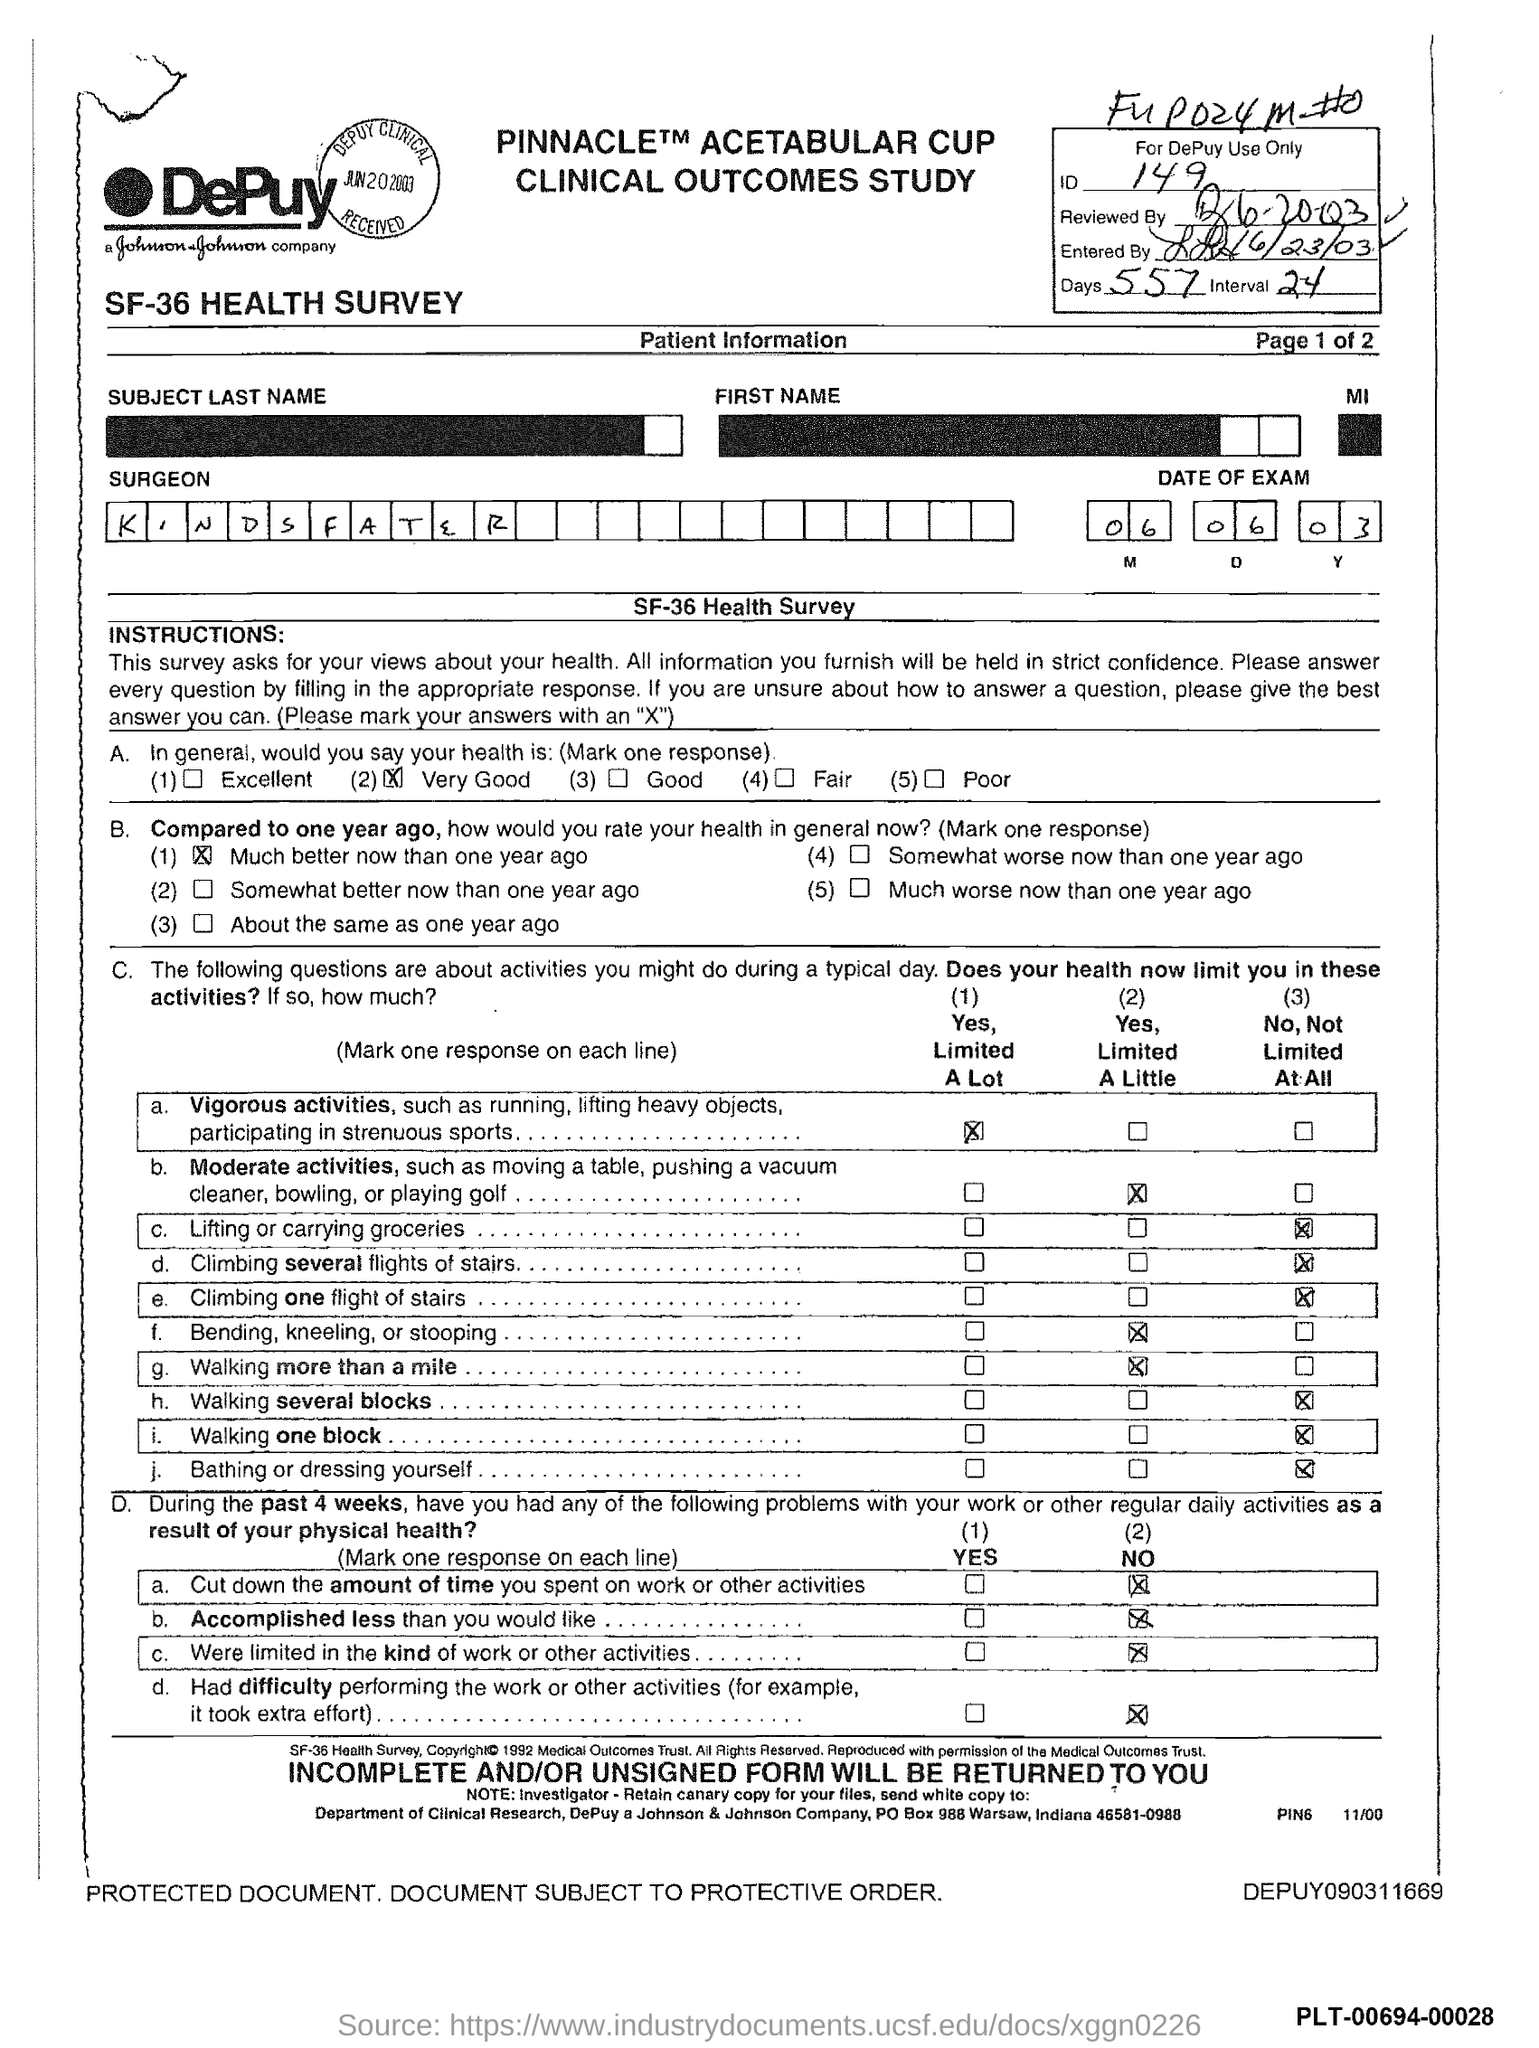What is the name of the Surgeon?
Keep it short and to the point. Kindsfater. What is the ID Number?
Your response must be concise. 149. 